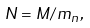<formula> <loc_0><loc_0><loc_500><loc_500>N = M / m _ { n } ,</formula> 